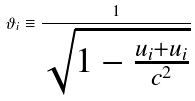<formula> <loc_0><loc_0><loc_500><loc_500>\vartheta _ { i } \equiv \frac { 1 } { \sqrt { 1 - \frac { u _ { i } + u _ { i } } { c ^ { 2 } } } }</formula> 